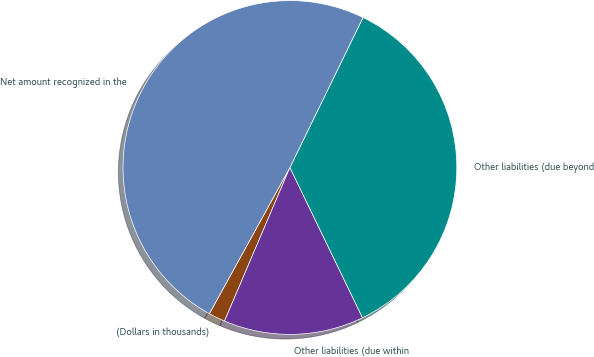Convert chart. <chart><loc_0><loc_0><loc_500><loc_500><pie_chart><fcel>(Dollars in thousands)<fcel>Other liabilities (due within<fcel>Other liabilities (due beyond<fcel>Net amount recognized in the<nl><fcel>1.61%<fcel>13.57%<fcel>35.62%<fcel>49.2%<nl></chart> 